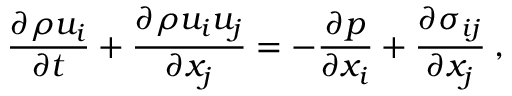<formula> <loc_0><loc_0><loc_500><loc_500>\frac { \partial \rho u _ { i } } { \partial t } + \frac { \partial \rho u _ { i } u _ { j } } { \partial x _ { j } } = - \frac { \partial p } { \partial x _ { i } } + \frac { \partial \sigma _ { i j } } { \partial x _ { j } } \, ,</formula> 